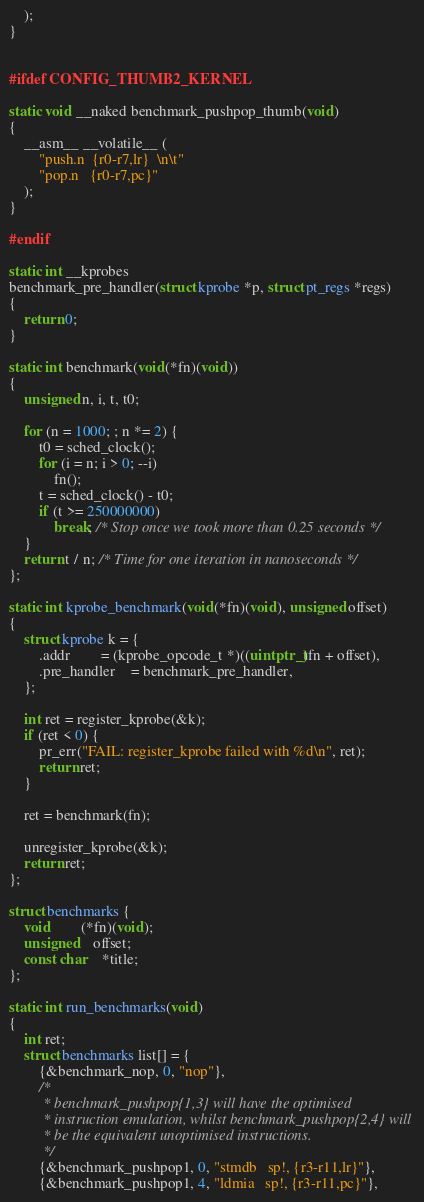Convert code to text. <code><loc_0><loc_0><loc_500><loc_500><_C_>	);
}


#ifdef CONFIG_THUMB2_KERNEL

static void __naked benchmark_pushpop_thumb(void)
{
	__asm__ __volatile__ (
		"push.n	{r0-r7,lr}  \n\t"
		"pop.n	{r0-r7,pc}"
	);
}

#endif

static int __kprobes
benchmark_pre_handler(struct kprobe *p, struct pt_regs *regs)
{
	return 0;
}

static int benchmark(void(*fn)(void))
{
	unsigned n, i, t, t0;

	for (n = 1000; ; n *= 2) {
		t0 = sched_clock();
		for (i = n; i > 0; --i)
			fn();
		t = sched_clock() - t0;
		if (t >= 250000000)
			break; /* Stop once we took more than 0.25 seconds */
	}
	return t / n; /* Time for one iteration in nanoseconds */
};

static int kprobe_benchmark(void(*fn)(void), unsigned offset)
{
	struct kprobe k = {
		.addr		= (kprobe_opcode_t *)((uintptr_t)fn + offset),
		.pre_handler	= benchmark_pre_handler,
	};

	int ret = register_kprobe(&k);
	if (ret < 0) {
		pr_err("FAIL: register_kprobe failed with %d\n", ret);
		return ret;
	}

	ret = benchmark(fn);

	unregister_kprobe(&k);
	return ret;
};

struct benchmarks {
	void		(*fn)(void);
	unsigned	offset;
	const char	*title;
};

static int run_benchmarks(void)
{
	int ret;
	struct benchmarks list[] = {
		{&benchmark_nop, 0, "nop"},
		/*
		 * benchmark_pushpop{1,3} will have the optimised
		 * instruction emulation, whilst benchmark_pushpop{2,4} will
		 * be the equivalent unoptimised instructions.
		 */
		{&benchmark_pushpop1, 0, "stmdb	sp!, {r3-r11,lr}"},
		{&benchmark_pushpop1, 4, "ldmia	sp!, {r3-r11,pc}"},</code> 